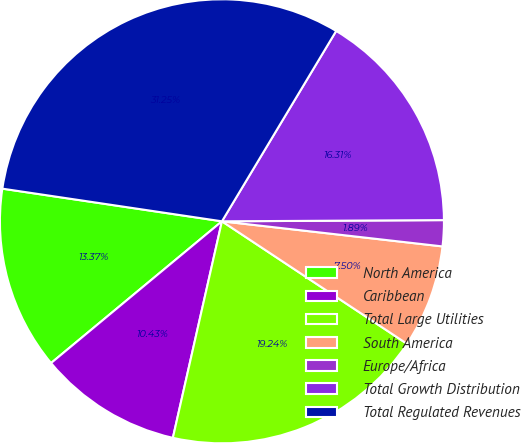Convert chart to OTSL. <chart><loc_0><loc_0><loc_500><loc_500><pie_chart><fcel>North America<fcel>Caribbean<fcel>Total Large Utilities<fcel>South America<fcel>Europe/Africa<fcel>Total Growth Distribution<fcel>Total Regulated Revenues<nl><fcel>13.37%<fcel>10.43%<fcel>19.24%<fcel>7.5%<fcel>1.89%<fcel>16.31%<fcel>31.25%<nl></chart> 